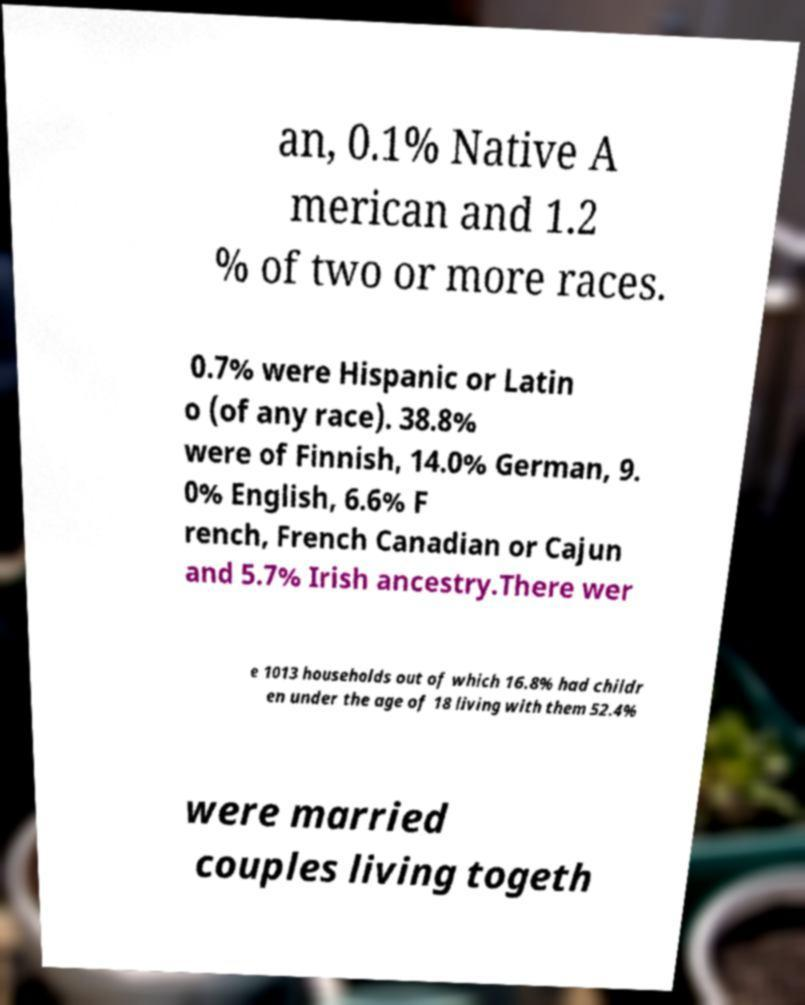For documentation purposes, I need the text within this image transcribed. Could you provide that? an, 0.1% Native A merican and 1.2 % of two or more races. 0.7% were Hispanic or Latin o (of any race). 38.8% were of Finnish, 14.0% German, 9. 0% English, 6.6% F rench, French Canadian or Cajun and 5.7% Irish ancestry.There wer e 1013 households out of which 16.8% had childr en under the age of 18 living with them 52.4% were married couples living togeth 